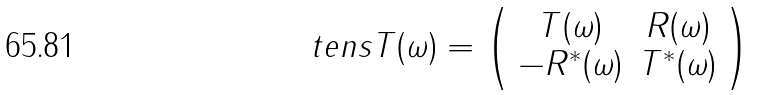Convert formula to latex. <formula><loc_0><loc_0><loc_500><loc_500>\ t e n s { T } ( \omega ) = \left ( \begin{array} { c c } T ( \omega ) & R ( \omega ) \\ - R ^ { \ast } ( \omega ) & T ^ { \ast } ( \omega ) \end{array} \right )</formula> 